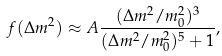Convert formula to latex. <formula><loc_0><loc_0><loc_500><loc_500>f ( \Delta m ^ { 2 } ) \approx A \frac { ( \Delta m ^ { 2 } / m _ { 0 } ^ { 2 } ) ^ { 3 } } { ( \Delta m ^ { 2 } / m _ { 0 } ^ { 2 } ) ^ { 5 } + 1 } ,</formula> 